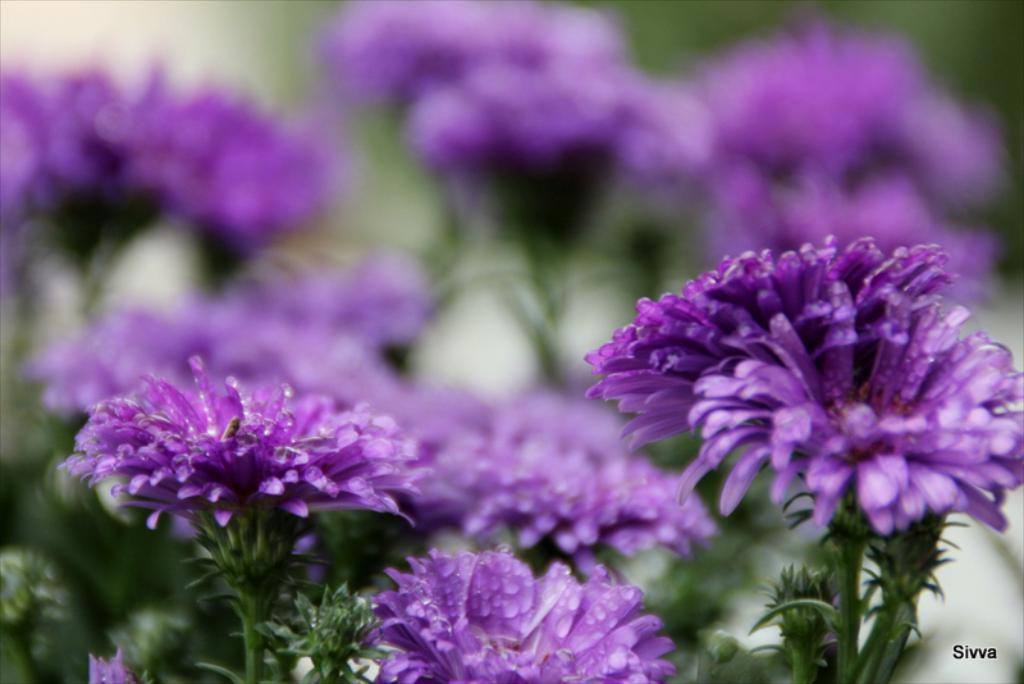Describe this image in one or two sentences. In this image we can see so many flowers to the plants, which are in purple color. 